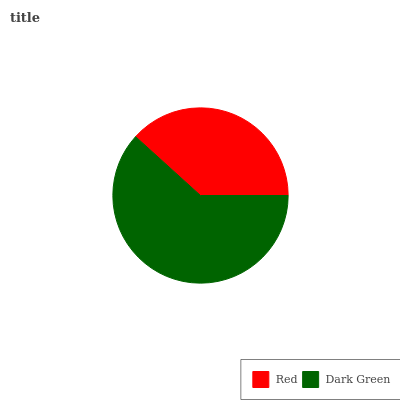Is Red the minimum?
Answer yes or no. Yes. Is Dark Green the maximum?
Answer yes or no. Yes. Is Dark Green the minimum?
Answer yes or no. No. Is Dark Green greater than Red?
Answer yes or no. Yes. Is Red less than Dark Green?
Answer yes or no. Yes. Is Red greater than Dark Green?
Answer yes or no. No. Is Dark Green less than Red?
Answer yes or no. No. Is Dark Green the high median?
Answer yes or no. Yes. Is Red the low median?
Answer yes or no. Yes. Is Red the high median?
Answer yes or no. No. Is Dark Green the low median?
Answer yes or no. No. 